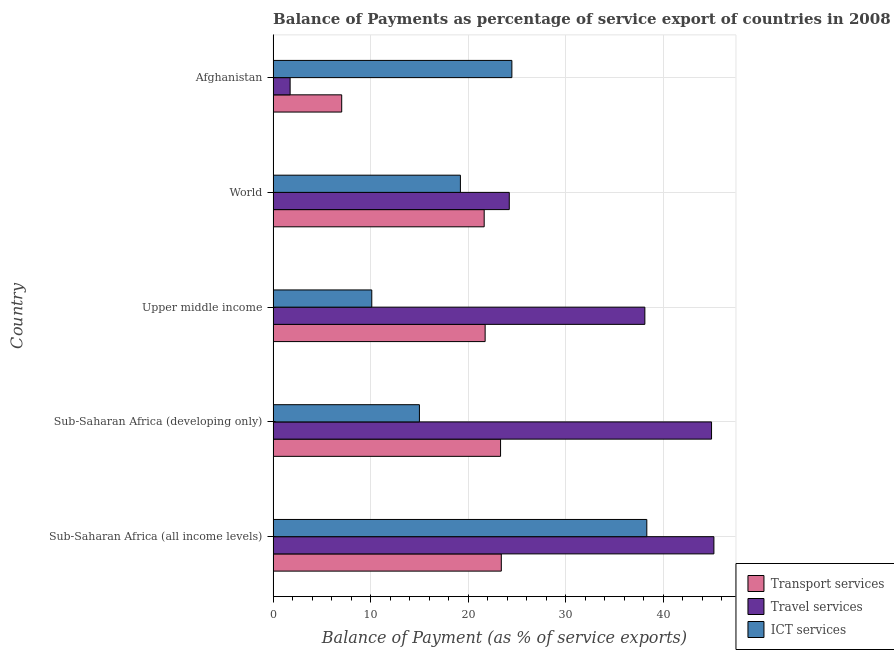How many groups of bars are there?
Your response must be concise. 5. How many bars are there on the 4th tick from the bottom?
Offer a terse response. 3. In how many cases, is the number of bars for a given country not equal to the number of legend labels?
Give a very brief answer. 0. What is the balance of payment of transport services in Afghanistan?
Ensure brevity in your answer.  7.03. Across all countries, what is the maximum balance of payment of travel services?
Make the answer very short. 45.19. Across all countries, what is the minimum balance of payment of ict services?
Provide a succinct answer. 10.11. In which country was the balance of payment of transport services maximum?
Provide a short and direct response. Sub-Saharan Africa (all income levels). In which country was the balance of payment of ict services minimum?
Your answer should be very brief. Upper middle income. What is the total balance of payment of transport services in the graph?
Your answer should be compact. 97.11. What is the difference between the balance of payment of travel services in Afghanistan and that in Upper middle income?
Your response must be concise. -36.37. What is the difference between the balance of payment of transport services in Sub-Saharan Africa (all income levels) and the balance of payment of ict services in Afghanistan?
Make the answer very short. -1.08. What is the average balance of payment of travel services per country?
Keep it short and to the point. 30.84. What is the difference between the balance of payment of travel services and balance of payment of transport services in Afghanistan?
Keep it short and to the point. -5.29. In how many countries, is the balance of payment of travel services greater than 38 %?
Ensure brevity in your answer.  3. Is the balance of payment of transport services in Afghanistan less than that in Upper middle income?
Ensure brevity in your answer.  Yes. Is the difference between the balance of payment of ict services in Afghanistan and World greater than the difference between the balance of payment of travel services in Afghanistan and World?
Keep it short and to the point. Yes. What is the difference between the highest and the second highest balance of payment of transport services?
Keep it short and to the point. 0.08. What is the difference between the highest and the lowest balance of payment of travel services?
Offer a very short reply. 43.44. In how many countries, is the balance of payment of ict services greater than the average balance of payment of ict services taken over all countries?
Give a very brief answer. 2. Is the sum of the balance of payment of travel services in Sub-Saharan Africa (developing only) and Upper middle income greater than the maximum balance of payment of transport services across all countries?
Your answer should be very brief. Yes. What does the 3rd bar from the top in Upper middle income represents?
Provide a succinct answer. Transport services. What does the 3rd bar from the bottom in Afghanistan represents?
Offer a very short reply. ICT services. Is it the case that in every country, the sum of the balance of payment of transport services and balance of payment of travel services is greater than the balance of payment of ict services?
Offer a very short reply. No. Are all the bars in the graph horizontal?
Your response must be concise. Yes. What is the difference between two consecutive major ticks on the X-axis?
Make the answer very short. 10. Are the values on the major ticks of X-axis written in scientific E-notation?
Your answer should be very brief. No. Does the graph contain any zero values?
Offer a very short reply. No. Where does the legend appear in the graph?
Keep it short and to the point. Bottom right. How many legend labels are there?
Provide a short and direct response. 3. How are the legend labels stacked?
Ensure brevity in your answer.  Vertical. What is the title of the graph?
Make the answer very short. Balance of Payments as percentage of service export of countries in 2008. What is the label or title of the X-axis?
Ensure brevity in your answer.  Balance of Payment (as % of service exports). What is the label or title of the Y-axis?
Offer a very short reply. Country. What is the Balance of Payment (as % of service exports) in Transport services in Sub-Saharan Africa (all income levels)?
Give a very brief answer. 23.39. What is the Balance of Payment (as % of service exports) in Travel services in Sub-Saharan Africa (all income levels)?
Provide a succinct answer. 45.19. What is the Balance of Payment (as % of service exports) of ICT services in Sub-Saharan Africa (all income levels)?
Provide a succinct answer. 38.31. What is the Balance of Payment (as % of service exports) in Transport services in Sub-Saharan Africa (developing only)?
Offer a terse response. 23.32. What is the Balance of Payment (as % of service exports) of Travel services in Sub-Saharan Africa (developing only)?
Keep it short and to the point. 44.94. What is the Balance of Payment (as % of service exports) in ICT services in Sub-Saharan Africa (developing only)?
Make the answer very short. 15. What is the Balance of Payment (as % of service exports) in Transport services in Upper middle income?
Provide a succinct answer. 21.73. What is the Balance of Payment (as % of service exports) in Travel services in Upper middle income?
Provide a succinct answer. 38.11. What is the Balance of Payment (as % of service exports) of ICT services in Upper middle income?
Make the answer very short. 10.11. What is the Balance of Payment (as % of service exports) in Transport services in World?
Your response must be concise. 21.64. What is the Balance of Payment (as % of service exports) of Travel services in World?
Your response must be concise. 24.21. What is the Balance of Payment (as % of service exports) in ICT services in World?
Offer a terse response. 19.2. What is the Balance of Payment (as % of service exports) of Transport services in Afghanistan?
Make the answer very short. 7.03. What is the Balance of Payment (as % of service exports) of Travel services in Afghanistan?
Your answer should be very brief. 1.74. What is the Balance of Payment (as % of service exports) in ICT services in Afghanistan?
Give a very brief answer. 24.47. Across all countries, what is the maximum Balance of Payment (as % of service exports) of Transport services?
Your answer should be very brief. 23.39. Across all countries, what is the maximum Balance of Payment (as % of service exports) in Travel services?
Your answer should be compact. 45.19. Across all countries, what is the maximum Balance of Payment (as % of service exports) in ICT services?
Keep it short and to the point. 38.31. Across all countries, what is the minimum Balance of Payment (as % of service exports) of Transport services?
Make the answer very short. 7.03. Across all countries, what is the minimum Balance of Payment (as % of service exports) of Travel services?
Your answer should be compact. 1.74. Across all countries, what is the minimum Balance of Payment (as % of service exports) of ICT services?
Provide a succinct answer. 10.11. What is the total Balance of Payment (as % of service exports) of Transport services in the graph?
Keep it short and to the point. 97.11. What is the total Balance of Payment (as % of service exports) in Travel services in the graph?
Make the answer very short. 154.19. What is the total Balance of Payment (as % of service exports) in ICT services in the graph?
Make the answer very short. 107.09. What is the difference between the Balance of Payment (as % of service exports) of Transport services in Sub-Saharan Africa (all income levels) and that in Sub-Saharan Africa (developing only)?
Provide a short and direct response. 0.08. What is the difference between the Balance of Payment (as % of service exports) of Travel services in Sub-Saharan Africa (all income levels) and that in Sub-Saharan Africa (developing only)?
Your answer should be very brief. 0.24. What is the difference between the Balance of Payment (as % of service exports) in ICT services in Sub-Saharan Africa (all income levels) and that in Sub-Saharan Africa (developing only)?
Ensure brevity in your answer.  23.31. What is the difference between the Balance of Payment (as % of service exports) of Transport services in Sub-Saharan Africa (all income levels) and that in Upper middle income?
Offer a very short reply. 1.66. What is the difference between the Balance of Payment (as % of service exports) of Travel services in Sub-Saharan Africa (all income levels) and that in Upper middle income?
Your answer should be compact. 7.08. What is the difference between the Balance of Payment (as % of service exports) in ICT services in Sub-Saharan Africa (all income levels) and that in Upper middle income?
Keep it short and to the point. 28.19. What is the difference between the Balance of Payment (as % of service exports) of Transport services in Sub-Saharan Africa (all income levels) and that in World?
Your answer should be very brief. 1.76. What is the difference between the Balance of Payment (as % of service exports) in Travel services in Sub-Saharan Africa (all income levels) and that in World?
Make the answer very short. 20.98. What is the difference between the Balance of Payment (as % of service exports) in ICT services in Sub-Saharan Africa (all income levels) and that in World?
Your answer should be compact. 19.11. What is the difference between the Balance of Payment (as % of service exports) in Transport services in Sub-Saharan Africa (all income levels) and that in Afghanistan?
Your answer should be very brief. 16.36. What is the difference between the Balance of Payment (as % of service exports) in Travel services in Sub-Saharan Africa (all income levels) and that in Afghanistan?
Your answer should be very brief. 43.44. What is the difference between the Balance of Payment (as % of service exports) of ICT services in Sub-Saharan Africa (all income levels) and that in Afghanistan?
Ensure brevity in your answer.  13.83. What is the difference between the Balance of Payment (as % of service exports) in Transport services in Sub-Saharan Africa (developing only) and that in Upper middle income?
Your answer should be very brief. 1.58. What is the difference between the Balance of Payment (as % of service exports) in Travel services in Sub-Saharan Africa (developing only) and that in Upper middle income?
Your answer should be compact. 6.84. What is the difference between the Balance of Payment (as % of service exports) of ICT services in Sub-Saharan Africa (developing only) and that in Upper middle income?
Your answer should be compact. 4.88. What is the difference between the Balance of Payment (as % of service exports) in Transport services in Sub-Saharan Africa (developing only) and that in World?
Make the answer very short. 1.68. What is the difference between the Balance of Payment (as % of service exports) of Travel services in Sub-Saharan Africa (developing only) and that in World?
Provide a short and direct response. 20.74. What is the difference between the Balance of Payment (as % of service exports) in ICT services in Sub-Saharan Africa (developing only) and that in World?
Keep it short and to the point. -4.2. What is the difference between the Balance of Payment (as % of service exports) in Transport services in Sub-Saharan Africa (developing only) and that in Afghanistan?
Your answer should be compact. 16.29. What is the difference between the Balance of Payment (as % of service exports) in Travel services in Sub-Saharan Africa (developing only) and that in Afghanistan?
Your response must be concise. 43.2. What is the difference between the Balance of Payment (as % of service exports) of ICT services in Sub-Saharan Africa (developing only) and that in Afghanistan?
Provide a succinct answer. -9.48. What is the difference between the Balance of Payment (as % of service exports) of Transport services in Upper middle income and that in World?
Keep it short and to the point. 0.1. What is the difference between the Balance of Payment (as % of service exports) of Travel services in Upper middle income and that in World?
Provide a succinct answer. 13.9. What is the difference between the Balance of Payment (as % of service exports) in ICT services in Upper middle income and that in World?
Your answer should be compact. -9.09. What is the difference between the Balance of Payment (as % of service exports) of Transport services in Upper middle income and that in Afghanistan?
Provide a succinct answer. 14.7. What is the difference between the Balance of Payment (as % of service exports) in Travel services in Upper middle income and that in Afghanistan?
Your response must be concise. 36.37. What is the difference between the Balance of Payment (as % of service exports) in ICT services in Upper middle income and that in Afghanistan?
Your answer should be very brief. -14.36. What is the difference between the Balance of Payment (as % of service exports) in Transport services in World and that in Afghanistan?
Give a very brief answer. 14.61. What is the difference between the Balance of Payment (as % of service exports) in Travel services in World and that in Afghanistan?
Your response must be concise. 22.47. What is the difference between the Balance of Payment (as % of service exports) of ICT services in World and that in Afghanistan?
Offer a very short reply. -5.28. What is the difference between the Balance of Payment (as % of service exports) in Transport services in Sub-Saharan Africa (all income levels) and the Balance of Payment (as % of service exports) in Travel services in Sub-Saharan Africa (developing only)?
Give a very brief answer. -21.55. What is the difference between the Balance of Payment (as % of service exports) of Transport services in Sub-Saharan Africa (all income levels) and the Balance of Payment (as % of service exports) of ICT services in Sub-Saharan Africa (developing only)?
Your answer should be very brief. 8.39. What is the difference between the Balance of Payment (as % of service exports) of Travel services in Sub-Saharan Africa (all income levels) and the Balance of Payment (as % of service exports) of ICT services in Sub-Saharan Africa (developing only)?
Your answer should be very brief. 30.19. What is the difference between the Balance of Payment (as % of service exports) in Transport services in Sub-Saharan Africa (all income levels) and the Balance of Payment (as % of service exports) in Travel services in Upper middle income?
Your answer should be very brief. -14.72. What is the difference between the Balance of Payment (as % of service exports) in Transport services in Sub-Saharan Africa (all income levels) and the Balance of Payment (as % of service exports) in ICT services in Upper middle income?
Provide a succinct answer. 13.28. What is the difference between the Balance of Payment (as % of service exports) in Travel services in Sub-Saharan Africa (all income levels) and the Balance of Payment (as % of service exports) in ICT services in Upper middle income?
Ensure brevity in your answer.  35.07. What is the difference between the Balance of Payment (as % of service exports) in Transport services in Sub-Saharan Africa (all income levels) and the Balance of Payment (as % of service exports) in Travel services in World?
Offer a terse response. -0.82. What is the difference between the Balance of Payment (as % of service exports) in Transport services in Sub-Saharan Africa (all income levels) and the Balance of Payment (as % of service exports) in ICT services in World?
Provide a short and direct response. 4.19. What is the difference between the Balance of Payment (as % of service exports) of Travel services in Sub-Saharan Africa (all income levels) and the Balance of Payment (as % of service exports) of ICT services in World?
Provide a short and direct response. 25.99. What is the difference between the Balance of Payment (as % of service exports) of Transport services in Sub-Saharan Africa (all income levels) and the Balance of Payment (as % of service exports) of Travel services in Afghanistan?
Offer a terse response. 21.65. What is the difference between the Balance of Payment (as % of service exports) in Transport services in Sub-Saharan Africa (all income levels) and the Balance of Payment (as % of service exports) in ICT services in Afghanistan?
Make the answer very short. -1.08. What is the difference between the Balance of Payment (as % of service exports) in Travel services in Sub-Saharan Africa (all income levels) and the Balance of Payment (as % of service exports) in ICT services in Afghanistan?
Offer a very short reply. 20.71. What is the difference between the Balance of Payment (as % of service exports) in Transport services in Sub-Saharan Africa (developing only) and the Balance of Payment (as % of service exports) in Travel services in Upper middle income?
Offer a very short reply. -14.79. What is the difference between the Balance of Payment (as % of service exports) of Transport services in Sub-Saharan Africa (developing only) and the Balance of Payment (as % of service exports) of ICT services in Upper middle income?
Offer a terse response. 13.2. What is the difference between the Balance of Payment (as % of service exports) of Travel services in Sub-Saharan Africa (developing only) and the Balance of Payment (as % of service exports) of ICT services in Upper middle income?
Offer a terse response. 34.83. What is the difference between the Balance of Payment (as % of service exports) in Transport services in Sub-Saharan Africa (developing only) and the Balance of Payment (as % of service exports) in Travel services in World?
Make the answer very short. -0.89. What is the difference between the Balance of Payment (as % of service exports) of Transport services in Sub-Saharan Africa (developing only) and the Balance of Payment (as % of service exports) of ICT services in World?
Your answer should be compact. 4.12. What is the difference between the Balance of Payment (as % of service exports) in Travel services in Sub-Saharan Africa (developing only) and the Balance of Payment (as % of service exports) in ICT services in World?
Your answer should be very brief. 25.74. What is the difference between the Balance of Payment (as % of service exports) in Transport services in Sub-Saharan Africa (developing only) and the Balance of Payment (as % of service exports) in Travel services in Afghanistan?
Offer a terse response. 21.57. What is the difference between the Balance of Payment (as % of service exports) of Transport services in Sub-Saharan Africa (developing only) and the Balance of Payment (as % of service exports) of ICT services in Afghanistan?
Make the answer very short. -1.16. What is the difference between the Balance of Payment (as % of service exports) in Travel services in Sub-Saharan Africa (developing only) and the Balance of Payment (as % of service exports) in ICT services in Afghanistan?
Make the answer very short. 20.47. What is the difference between the Balance of Payment (as % of service exports) in Transport services in Upper middle income and the Balance of Payment (as % of service exports) in Travel services in World?
Make the answer very short. -2.47. What is the difference between the Balance of Payment (as % of service exports) of Transport services in Upper middle income and the Balance of Payment (as % of service exports) of ICT services in World?
Offer a terse response. 2.53. What is the difference between the Balance of Payment (as % of service exports) of Travel services in Upper middle income and the Balance of Payment (as % of service exports) of ICT services in World?
Offer a terse response. 18.91. What is the difference between the Balance of Payment (as % of service exports) of Transport services in Upper middle income and the Balance of Payment (as % of service exports) of Travel services in Afghanistan?
Your answer should be compact. 19.99. What is the difference between the Balance of Payment (as % of service exports) of Transport services in Upper middle income and the Balance of Payment (as % of service exports) of ICT services in Afghanistan?
Your response must be concise. -2.74. What is the difference between the Balance of Payment (as % of service exports) of Travel services in Upper middle income and the Balance of Payment (as % of service exports) of ICT services in Afghanistan?
Your response must be concise. 13.63. What is the difference between the Balance of Payment (as % of service exports) of Transport services in World and the Balance of Payment (as % of service exports) of Travel services in Afghanistan?
Provide a succinct answer. 19.89. What is the difference between the Balance of Payment (as % of service exports) in Transport services in World and the Balance of Payment (as % of service exports) in ICT services in Afghanistan?
Offer a terse response. -2.84. What is the difference between the Balance of Payment (as % of service exports) in Travel services in World and the Balance of Payment (as % of service exports) in ICT services in Afghanistan?
Provide a short and direct response. -0.27. What is the average Balance of Payment (as % of service exports) of Transport services per country?
Offer a terse response. 19.42. What is the average Balance of Payment (as % of service exports) of Travel services per country?
Keep it short and to the point. 30.84. What is the average Balance of Payment (as % of service exports) of ICT services per country?
Provide a short and direct response. 21.42. What is the difference between the Balance of Payment (as % of service exports) in Transport services and Balance of Payment (as % of service exports) in Travel services in Sub-Saharan Africa (all income levels)?
Give a very brief answer. -21.79. What is the difference between the Balance of Payment (as % of service exports) of Transport services and Balance of Payment (as % of service exports) of ICT services in Sub-Saharan Africa (all income levels)?
Keep it short and to the point. -14.91. What is the difference between the Balance of Payment (as % of service exports) of Travel services and Balance of Payment (as % of service exports) of ICT services in Sub-Saharan Africa (all income levels)?
Your answer should be very brief. 6.88. What is the difference between the Balance of Payment (as % of service exports) of Transport services and Balance of Payment (as % of service exports) of Travel services in Sub-Saharan Africa (developing only)?
Your answer should be compact. -21.63. What is the difference between the Balance of Payment (as % of service exports) in Transport services and Balance of Payment (as % of service exports) in ICT services in Sub-Saharan Africa (developing only)?
Offer a very short reply. 8.32. What is the difference between the Balance of Payment (as % of service exports) of Travel services and Balance of Payment (as % of service exports) of ICT services in Sub-Saharan Africa (developing only)?
Make the answer very short. 29.95. What is the difference between the Balance of Payment (as % of service exports) of Transport services and Balance of Payment (as % of service exports) of Travel services in Upper middle income?
Your response must be concise. -16.37. What is the difference between the Balance of Payment (as % of service exports) of Transport services and Balance of Payment (as % of service exports) of ICT services in Upper middle income?
Offer a terse response. 11.62. What is the difference between the Balance of Payment (as % of service exports) of Travel services and Balance of Payment (as % of service exports) of ICT services in Upper middle income?
Keep it short and to the point. 28. What is the difference between the Balance of Payment (as % of service exports) of Transport services and Balance of Payment (as % of service exports) of Travel services in World?
Ensure brevity in your answer.  -2.57. What is the difference between the Balance of Payment (as % of service exports) of Transport services and Balance of Payment (as % of service exports) of ICT services in World?
Your answer should be compact. 2.44. What is the difference between the Balance of Payment (as % of service exports) of Travel services and Balance of Payment (as % of service exports) of ICT services in World?
Give a very brief answer. 5.01. What is the difference between the Balance of Payment (as % of service exports) in Transport services and Balance of Payment (as % of service exports) in Travel services in Afghanistan?
Offer a terse response. 5.29. What is the difference between the Balance of Payment (as % of service exports) in Transport services and Balance of Payment (as % of service exports) in ICT services in Afghanistan?
Give a very brief answer. -17.44. What is the difference between the Balance of Payment (as % of service exports) of Travel services and Balance of Payment (as % of service exports) of ICT services in Afghanistan?
Offer a terse response. -22.73. What is the ratio of the Balance of Payment (as % of service exports) in Transport services in Sub-Saharan Africa (all income levels) to that in Sub-Saharan Africa (developing only)?
Offer a terse response. 1. What is the ratio of the Balance of Payment (as % of service exports) in Travel services in Sub-Saharan Africa (all income levels) to that in Sub-Saharan Africa (developing only)?
Ensure brevity in your answer.  1.01. What is the ratio of the Balance of Payment (as % of service exports) in ICT services in Sub-Saharan Africa (all income levels) to that in Sub-Saharan Africa (developing only)?
Provide a succinct answer. 2.55. What is the ratio of the Balance of Payment (as % of service exports) of Transport services in Sub-Saharan Africa (all income levels) to that in Upper middle income?
Make the answer very short. 1.08. What is the ratio of the Balance of Payment (as % of service exports) of Travel services in Sub-Saharan Africa (all income levels) to that in Upper middle income?
Provide a short and direct response. 1.19. What is the ratio of the Balance of Payment (as % of service exports) of ICT services in Sub-Saharan Africa (all income levels) to that in Upper middle income?
Offer a terse response. 3.79. What is the ratio of the Balance of Payment (as % of service exports) of Transport services in Sub-Saharan Africa (all income levels) to that in World?
Provide a succinct answer. 1.08. What is the ratio of the Balance of Payment (as % of service exports) in Travel services in Sub-Saharan Africa (all income levels) to that in World?
Give a very brief answer. 1.87. What is the ratio of the Balance of Payment (as % of service exports) in ICT services in Sub-Saharan Africa (all income levels) to that in World?
Your answer should be very brief. 2. What is the ratio of the Balance of Payment (as % of service exports) in Transport services in Sub-Saharan Africa (all income levels) to that in Afghanistan?
Give a very brief answer. 3.33. What is the ratio of the Balance of Payment (as % of service exports) in Travel services in Sub-Saharan Africa (all income levels) to that in Afghanistan?
Your response must be concise. 25.92. What is the ratio of the Balance of Payment (as % of service exports) in ICT services in Sub-Saharan Africa (all income levels) to that in Afghanistan?
Make the answer very short. 1.57. What is the ratio of the Balance of Payment (as % of service exports) of Transport services in Sub-Saharan Africa (developing only) to that in Upper middle income?
Provide a short and direct response. 1.07. What is the ratio of the Balance of Payment (as % of service exports) in Travel services in Sub-Saharan Africa (developing only) to that in Upper middle income?
Your response must be concise. 1.18. What is the ratio of the Balance of Payment (as % of service exports) in ICT services in Sub-Saharan Africa (developing only) to that in Upper middle income?
Your answer should be compact. 1.48. What is the ratio of the Balance of Payment (as % of service exports) of Transport services in Sub-Saharan Africa (developing only) to that in World?
Offer a very short reply. 1.08. What is the ratio of the Balance of Payment (as % of service exports) in Travel services in Sub-Saharan Africa (developing only) to that in World?
Keep it short and to the point. 1.86. What is the ratio of the Balance of Payment (as % of service exports) in ICT services in Sub-Saharan Africa (developing only) to that in World?
Your answer should be compact. 0.78. What is the ratio of the Balance of Payment (as % of service exports) of Transport services in Sub-Saharan Africa (developing only) to that in Afghanistan?
Provide a succinct answer. 3.32. What is the ratio of the Balance of Payment (as % of service exports) of Travel services in Sub-Saharan Africa (developing only) to that in Afghanistan?
Make the answer very short. 25.78. What is the ratio of the Balance of Payment (as % of service exports) of ICT services in Sub-Saharan Africa (developing only) to that in Afghanistan?
Provide a short and direct response. 0.61. What is the ratio of the Balance of Payment (as % of service exports) of Transport services in Upper middle income to that in World?
Keep it short and to the point. 1. What is the ratio of the Balance of Payment (as % of service exports) of Travel services in Upper middle income to that in World?
Ensure brevity in your answer.  1.57. What is the ratio of the Balance of Payment (as % of service exports) of ICT services in Upper middle income to that in World?
Your response must be concise. 0.53. What is the ratio of the Balance of Payment (as % of service exports) of Transport services in Upper middle income to that in Afghanistan?
Provide a succinct answer. 3.09. What is the ratio of the Balance of Payment (as % of service exports) of Travel services in Upper middle income to that in Afghanistan?
Offer a terse response. 21.86. What is the ratio of the Balance of Payment (as % of service exports) of ICT services in Upper middle income to that in Afghanistan?
Offer a very short reply. 0.41. What is the ratio of the Balance of Payment (as % of service exports) of Transport services in World to that in Afghanistan?
Offer a very short reply. 3.08. What is the ratio of the Balance of Payment (as % of service exports) of Travel services in World to that in Afghanistan?
Your answer should be compact. 13.88. What is the ratio of the Balance of Payment (as % of service exports) in ICT services in World to that in Afghanistan?
Your answer should be compact. 0.78. What is the difference between the highest and the second highest Balance of Payment (as % of service exports) in Transport services?
Offer a very short reply. 0.08. What is the difference between the highest and the second highest Balance of Payment (as % of service exports) of Travel services?
Ensure brevity in your answer.  0.24. What is the difference between the highest and the second highest Balance of Payment (as % of service exports) of ICT services?
Make the answer very short. 13.83. What is the difference between the highest and the lowest Balance of Payment (as % of service exports) of Transport services?
Provide a succinct answer. 16.36. What is the difference between the highest and the lowest Balance of Payment (as % of service exports) in Travel services?
Your answer should be compact. 43.44. What is the difference between the highest and the lowest Balance of Payment (as % of service exports) in ICT services?
Give a very brief answer. 28.19. 